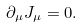<formula> <loc_0><loc_0><loc_500><loc_500>\partial _ { \mu } J _ { \mu } = 0 .</formula> 